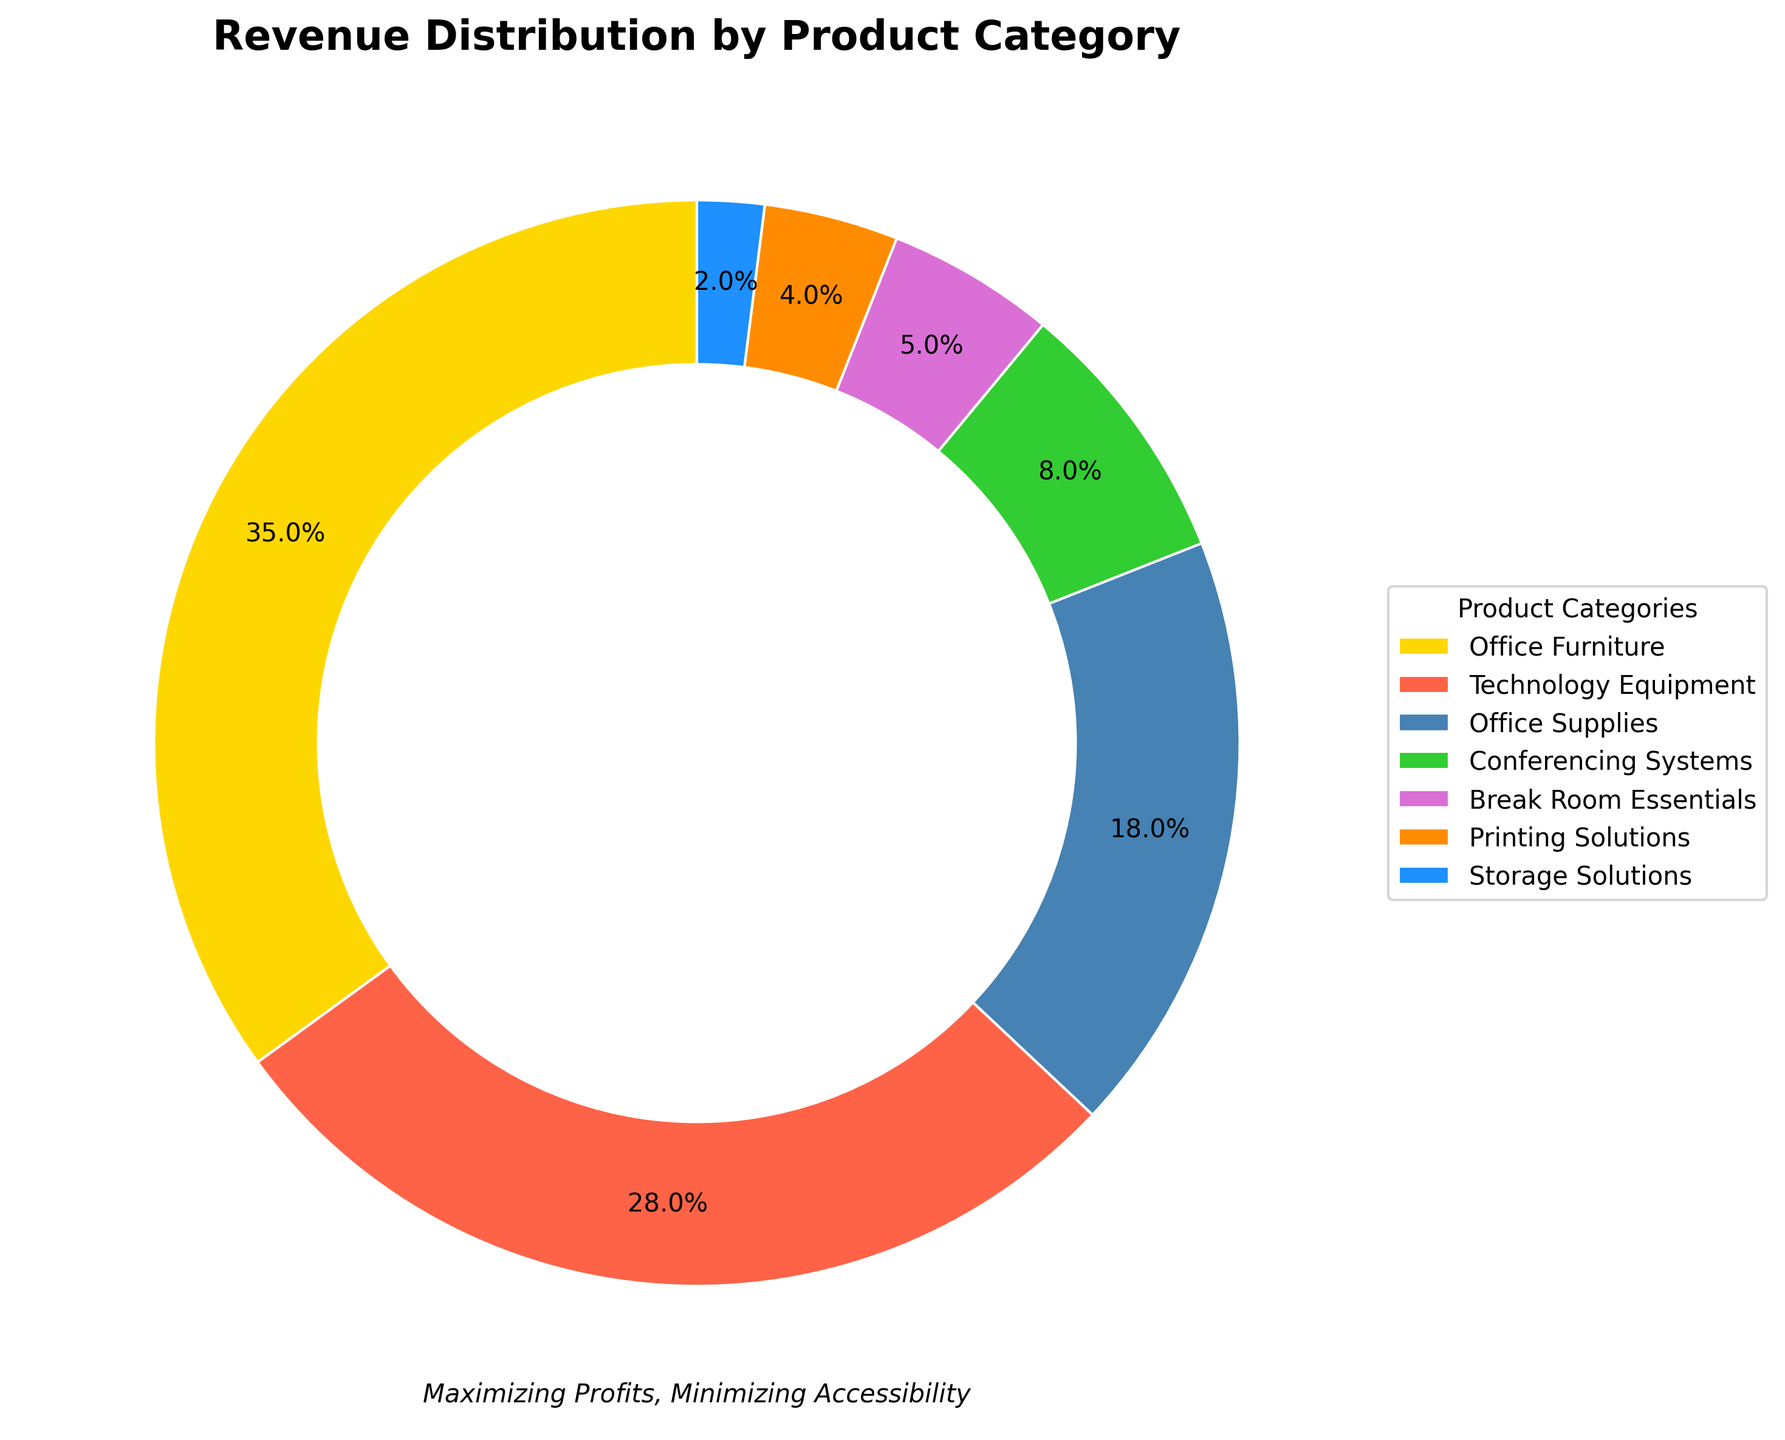Which product category generates the highest revenue percentage? The pie chart visually shows that the segment labeled "Office Furniture" covers the largest portion of the plot, indicating the highest revenue percentage.
Answer: Office Furniture What is the combined revenue percentage of Office Supplies and Conferencing Systems? Add the percentages of Office Supplies (18%) and Conferencing Systems (8%). 18 + 8 = 26.
Answer: 26% Which category contributes more to the revenue, Technology Equipment or Break Room Essentials? Compare the sizes of the slices: Technology Equipment (28%) is larger than Break Room Essentials (5%).
Answer: Technology Equipment What is the percentage difference between Office Furniture and Technology Equipment? Subtract the percentage of Technology Equipment (28%) from that of Office Furniture (35%). 35 - 28 = 7.
Answer: 7% Which category is represented by the dark blue segment of the chart? The legend associates each color with a product category; the dark blue segment corresponds to "Storage Solutions".
Answer: Storage Solutions Are there any categories with less than 5% revenue contribution? If so, which ones? Scan the chart for the smallest segments: Storage Solutions has a 2% revenue contribution.
Answer: Storage Solutions Is the revenue percentage for Conferencing Systems greater than that for Printing Solutions? According to the chart, Conferencing Systems (8%) has a larger percentage than Printing Solutions (4%).
Answer: Yes What is the total revenue percentage of all categories that contribute less than 10% each? Add the percentages of Conferencing Systems (8%), Break Room Essentials (5%), Printing Solutions (4%), and Storage Solutions (2%). 8 + 5 + 4 + 2 = 19.
Answer: 19% Which product category is displayed in green, and what is its revenue percentage? The green slice corresponds to Conferencing Systems, as identified by the legend. The chart shows an 8% revenue percentage for Conferencing Systems.
Answer: Conferencing Systems, 8% What is the average revenue percentage of the top three revenue-generating product categories? Identify the top three categories: Office Furniture (35%), Technology Equipment (28%), and Office Supplies (18%). Calculate their average: (35 + 28 + 18) / 3 = 27%.
Answer: 27% 